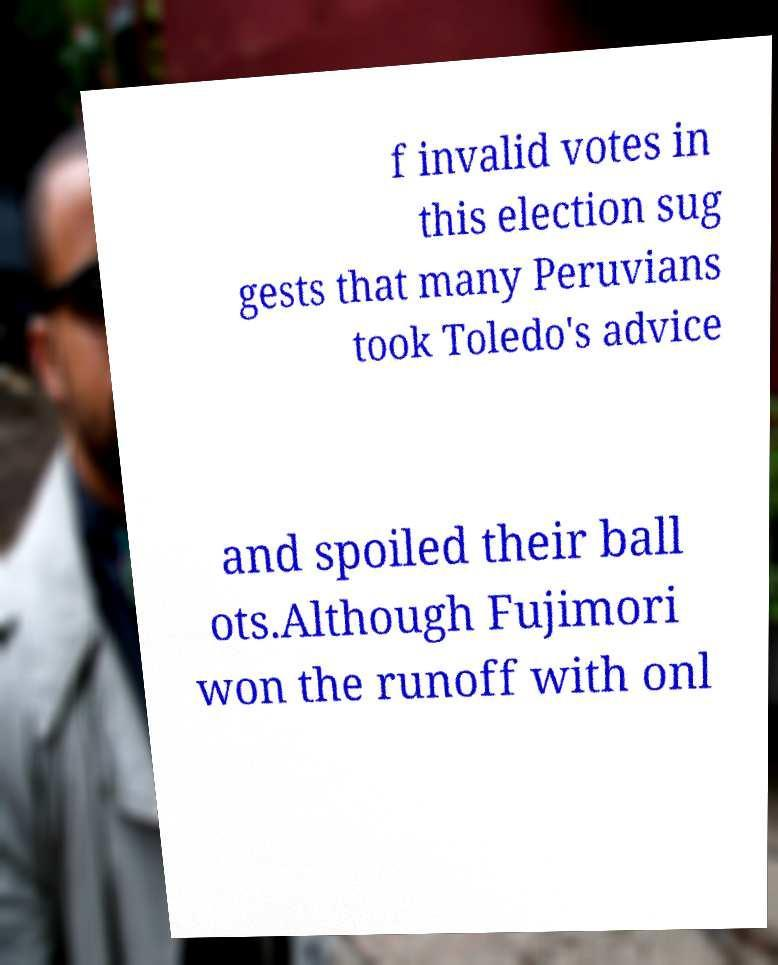Can you accurately transcribe the text from the provided image for me? f invalid votes in this election sug gests that many Peruvians took Toledo's advice and spoiled their ball ots.Although Fujimori won the runoff with onl 